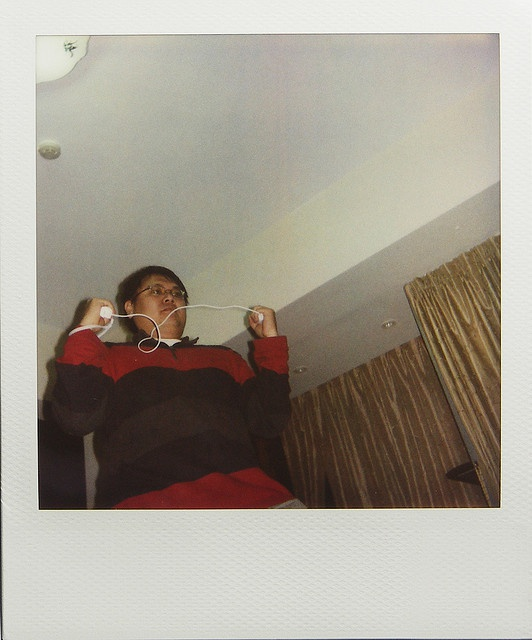Describe the objects in this image and their specific colors. I can see people in white, black, maroon, and gray tones, remote in white, lightgray, and tan tones, and remote in white, darkgray, gray, tan, and lightgray tones in this image. 